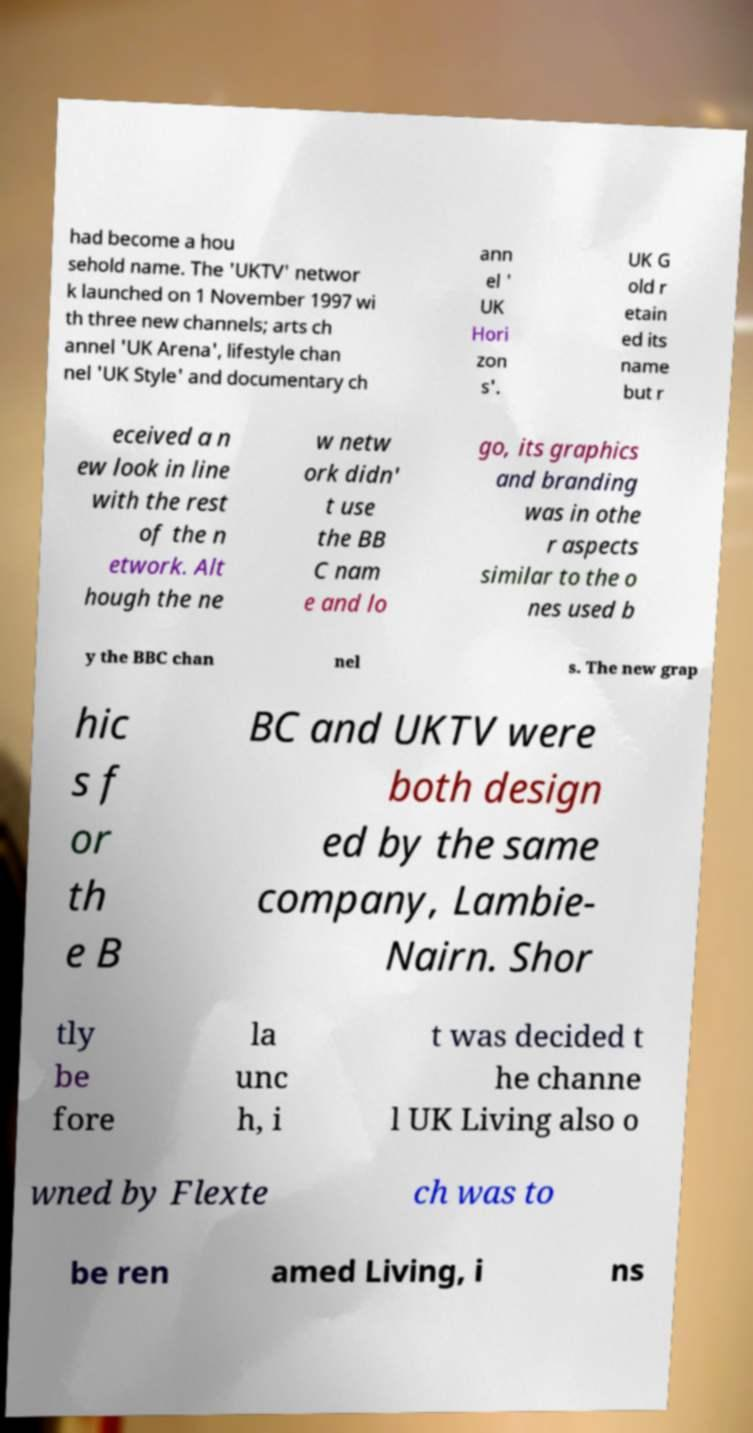Please read and relay the text visible in this image. What does it say? had become a hou sehold name. The 'UKTV' networ k launched on 1 November 1997 wi th three new channels; arts ch annel 'UK Arena', lifestyle chan nel 'UK Style' and documentary ch ann el ' UK Hori zon s'. UK G old r etain ed its name but r eceived a n ew look in line with the rest of the n etwork. Alt hough the ne w netw ork didn' t use the BB C nam e and lo go, its graphics and branding was in othe r aspects similar to the o nes used b y the BBC chan nel s. The new grap hic s f or th e B BC and UKTV were both design ed by the same company, Lambie- Nairn. Shor tly be fore la unc h, i t was decided t he channe l UK Living also o wned by Flexte ch was to be ren amed Living, i ns 